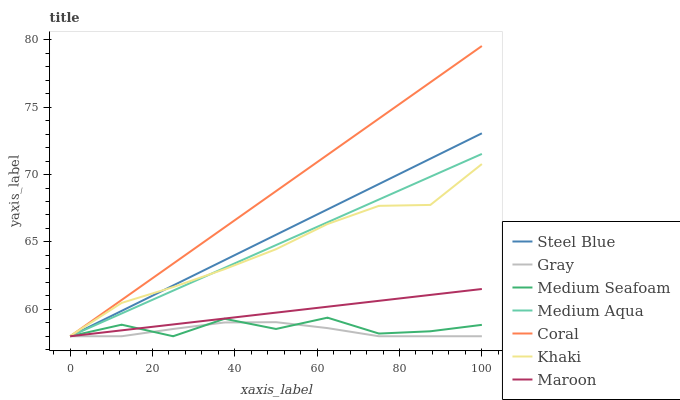Does Gray have the minimum area under the curve?
Answer yes or no. Yes. Does Coral have the maximum area under the curve?
Answer yes or no. Yes. Does Khaki have the minimum area under the curve?
Answer yes or no. No. Does Khaki have the maximum area under the curve?
Answer yes or no. No. Is Medium Aqua the smoothest?
Answer yes or no. Yes. Is Medium Seafoam the roughest?
Answer yes or no. Yes. Is Khaki the smoothest?
Answer yes or no. No. Is Khaki the roughest?
Answer yes or no. No. Does Gray have the lowest value?
Answer yes or no. Yes. Does Khaki have the lowest value?
Answer yes or no. No. Does Coral have the highest value?
Answer yes or no. Yes. Does Khaki have the highest value?
Answer yes or no. No. Is Medium Seafoam less than Khaki?
Answer yes or no. Yes. Is Khaki greater than Medium Seafoam?
Answer yes or no. Yes. Does Steel Blue intersect Gray?
Answer yes or no. Yes. Is Steel Blue less than Gray?
Answer yes or no. No. Is Steel Blue greater than Gray?
Answer yes or no. No. Does Medium Seafoam intersect Khaki?
Answer yes or no. No. 